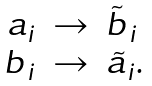<formula> <loc_0><loc_0><loc_500><loc_500>\begin{array} { r c l } a _ { i } & \to & \tilde { b } _ { \, i } \\ b _ { \, i } & \to & \tilde { a } _ { i } . \end{array}</formula> 